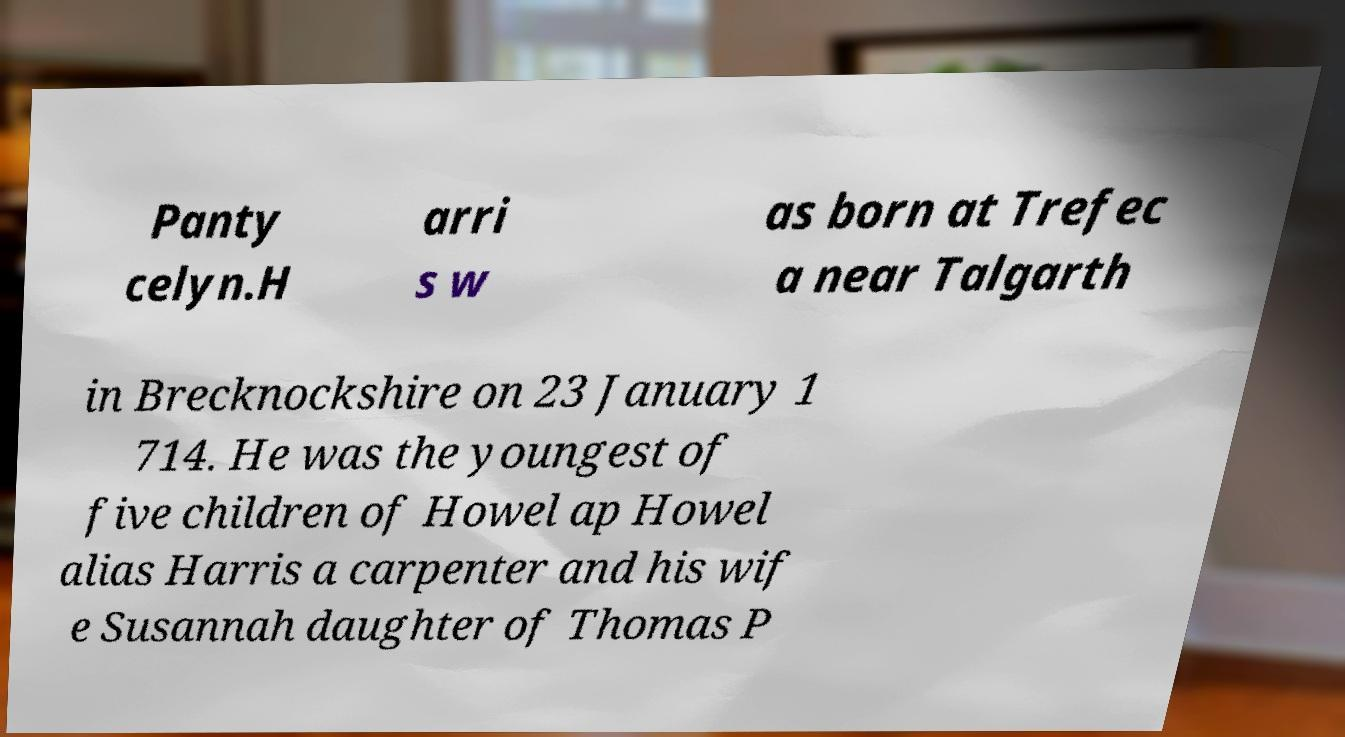For documentation purposes, I need the text within this image transcribed. Could you provide that? Panty celyn.H arri s w as born at Trefec a near Talgarth in Brecknockshire on 23 January 1 714. He was the youngest of five children of Howel ap Howel alias Harris a carpenter and his wif e Susannah daughter of Thomas P 